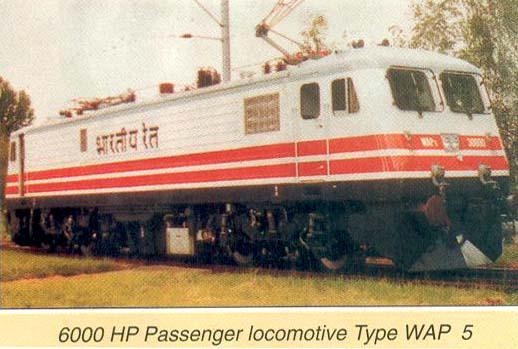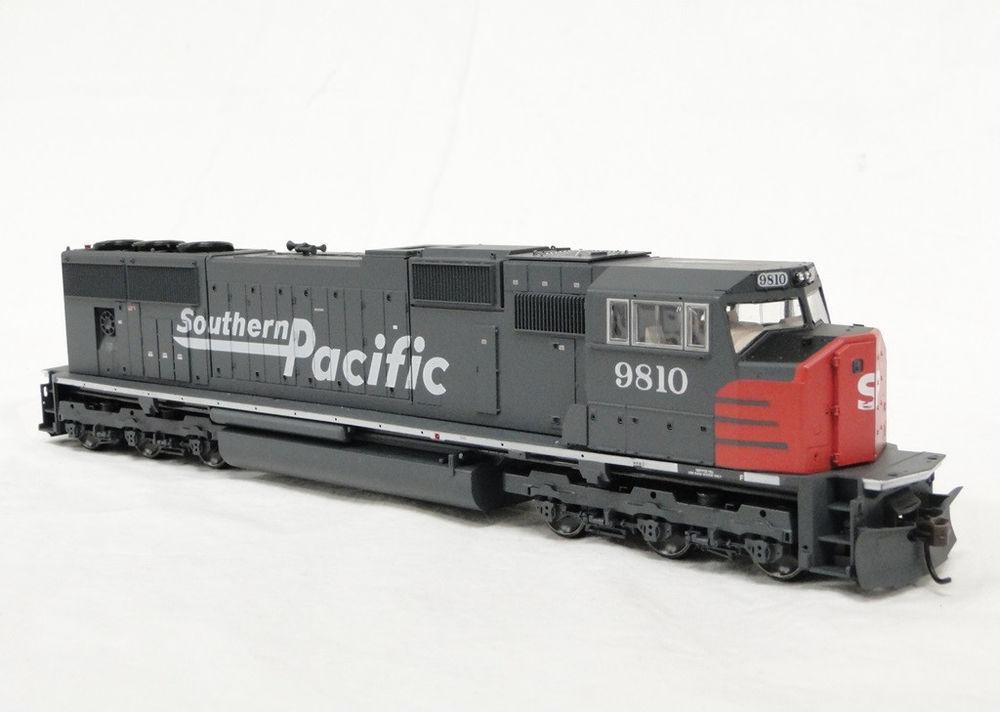The first image is the image on the left, the second image is the image on the right. Given the left and right images, does the statement "Power lines can be seen above the train in the image on the right." hold true? Answer yes or no. No. 